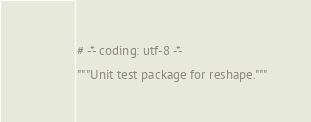Convert code to text. <code><loc_0><loc_0><loc_500><loc_500><_Python_># -*- coding: utf-8 -*-

"""Unit test package for reshape."""
</code> 